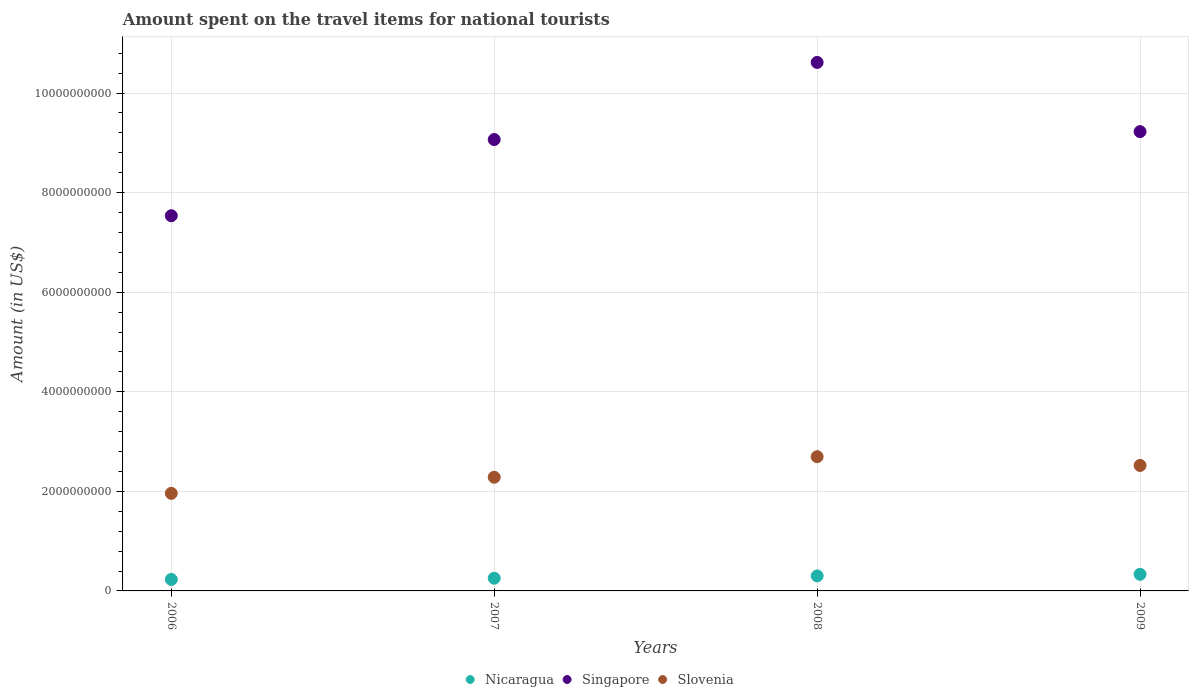Is the number of dotlines equal to the number of legend labels?
Offer a very short reply. Yes. What is the amount spent on the travel items for national tourists in Singapore in 2007?
Your answer should be compact. 9.07e+09. Across all years, what is the maximum amount spent on the travel items for national tourists in Slovenia?
Give a very brief answer. 2.70e+09. Across all years, what is the minimum amount spent on the travel items for national tourists in Slovenia?
Your answer should be compact. 1.96e+09. In which year was the amount spent on the travel items for national tourists in Nicaragua maximum?
Give a very brief answer. 2009. What is the total amount spent on the travel items for national tourists in Slovenia in the graph?
Offer a very short reply. 9.46e+09. What is the difference between the amount spent on the travel items for national tourists in Slovenia in 2007 and that in 2008?
Your answer should be very brief. -4.13e+08. What is the difference between the amount spent on the travel items for national tourists in Nicaragua in 2006 and the amount spent on the travel items for national tourists in Singapore in 2007?
Provide a short and direct response. -8.84e+09. What is the average amount spent on the travel items for national tourists in Singapore per year?
Offer a very short reply. 9.11e+09. In the year 2007, what is the difference between the amount spent on the travel items for national tourists in Slovenia and amount spent on the travel items for national tourists in Nicaragua?
Ensure brevity in your answer.  2.03e+09. What is the ratio of the amount spent on the travel items for national tourists in Slovenia in 2006 to that in 2008?
Ensure brevity in your answer.  0.73. Is the amount spent on the travel items for national tourists in Singapore in 2007 less than that in 2009?
Ensure brevity in your answer.  Yes. Is the difference between the amount spent on the travel items for national tourists in Slovenia in 2006 and 2009 greater than the difference between the amount spent on the travel items for national tourists in Nicaragua in 2006 and 2009?
Make the answer very short. No. What is the difference between the highest and the second highest amount spent on the travel items for national tourists in Singapore?
Your response must be concise. 1.39e+09. What is the difference between the highest and the lowest amount spent on the travel items for national tourists in Slovenia?
Provide a succinct answer. 7.36e+08. Does the amount spent on the travel items for national tourists in Slovenia monotonically increase over the years?
Your response must be concise. No. Is the amount spent on the travel items for national tourists in Slovenia strictly greater than the amount spent on the travel items for national tourists in Singapore over the years?
Offer a terse response. No. Is the amount spent on the travel items for national tourists in Singapore strictly less than the amount spent on the travel items for national tourists in Slovenia over the years?
Offer a terse response. No. How many dotlines are there?
Make the answer very short. 3. How many years are there in the graph?
Make the answer very short. 4. Are the values on the major ticks of Y-axis written in scientific E-notation?
Provide a short and direct response. No. Does the graph contain grids?
Offer a very short reply. Yes. How many legend labels are there?
Ensure brevity in your answer.  3. How are the legend labels stacked?
Keep it short and to the point. Horizontal. What is the title of the graph?
Offer a terse response. Amount spent on the travel items for national tourists. Does "Least developed countries" appear as one of the legend labels in the graph?
Provide a succinct answer. No. What is the label or title of the Y-axis?
Ensure brevity in your answer.  Amount (in US$). What is the Amount (in US$) in Nicaragua in 2006?
Provide a succinct answer. 2.31e+08. What is the Amount (in US$) of Singapore in 2006?
Offer a terse response. 7.54e+09. What is the Amount (in US$) of Slovenia in 2006?
Provide a short and direct response. 1.96e+09. What is the Amount (in US$) in Nicaragua in 2007?
Your response must be concise. 2.55e+08. What is the Amount (in US$) in Singapore in 2007?
Provide a short and direct response. 9.07e+09. What is the Amount (in US$) in Slovenia in 2007?
Ensure brevity in your answer.  2.28e+09. What is the Amount (in US$) of Nicaragua in 2008?
Provide a short and direct response. 3.01e+08. What is the Amount (in US$) of Singapore in 2008?
Your response must be concise. 1.06e+1. What is the Amount (in US$) in Slovenia in 2008?
Make the answer very short. 2.70e+09. What is the Amount (in US$) of Nicaragua in 2009?
Your answer should be very brief. 3.34e+08. What is the Amount (in US$) of Singapore in 2009?
Provide a short and direct response. 9.22e+09. What is the Amount (in US$) of Slovenia in 2009?
Offer a very short reply. 2.52e+09. Across all years, what is the maximum Amount (in US$) of Nicaragua?
Give a very brief answer. 3.34e+08. Across all years, what is the maximum Amount (in US$) in Singapore?
Make the answer very short. 1.06e+1. Across all years, what is the maximum Amount (in US$) in Slovenia?
Give a very brief answer. 2.70e+09. Across all years, what is the minimum Amount (in US$) of Nicaragua?
Offer a very short reply. 2.31e+08. Across all years, what is the minimum Amount (in US$) of Singapore?
Your answer should be very brief. 7.54e+09. Across all years, what is the minimum Amount (in US$) in Slovenia?
Provide a short and direct response. 1.96e+09. What is the total Amount (in US$) in Nicaragua in the graph?
Give a very brief answer. 1.12e+09. What is the total Amount (in US$) in Singapore in the graph?
Your answer should be very brief. 3.64e+1. What is the total Amount (in US$) in Slovenia in the graph?
Your response must be concise. 9.46e+09. What is the difference between the Amount (in US$) of Nicaragua in 2006 and that in 2007?
Your answer should be very brief. -2.40e+07. What is the difference between the Amount (in US$) of Singapore in 2006 and that in 2007?
Provide a short and direct response. -1.53e+09. What is the difference between the Amount (in US$) in Slovenia in 2006 and that in 2007?
Your answer should be very brief. -3.23e+08. What is the difference between the Amount (in US$) in Nicaragua in 2006 and that in 2008?
Your answer should be very brief. -7.00e+07. What is the difference between the Amount (in US$) in Singapore in 2006 and that in 2008?
Your response must be concise. -3.08e+09. What is the difference between the Amount (in US$) in Slovenia in 2006 and that in 2008?
Keep it short and to the point. -7.36e+08. What is the difference between the Amount (in US$) in Nicaragua in 2006 and that in 2009?
Offer a terse response. -1.03e+08. What is the difference between the Amount (in US$) of Singapore in 2006 and that in 2009?
Keep it short and to the point. -1.69e+09. What is the difference between the Amount (in US$) of Slovenia in 2006 and that in 2009?
Provide a succinct answer. -5.60e+08. What is the difference between the Amount (in US$) of Nicaragua in 2007 and that in 2008?
Keep it short and to the point. -4.60e+07. What is the difference between the Amount (in US$) in Singapore in 2007 and that in 2008?
Your answer should be compact. -1.55e+09. What is the difference between the Amount (in US$) of Slovenia in 2007 and that in 2008?
Provide a succinct answer. -4.13e+08. What is the difference between the Amount (in US$) of Nicaragua in 2007 and that in 2009?
Your response must be concise. -7.90e+07. What is the difference between the Amount (in US$) of Singapore in 2007 and that in 2009?
Ensure brevity in your answer.  -1.59e+08. What is the difference between the Amount (in US$) of Slovenia in 2007 and that in 2009?
Your answer should be compact. -2.37e+08. What is the difference between the Amount (in US$) in Nicaragua in 2008 and that in 2009?
Your answer should be very brief. -3.30e+07. What is the difference between the Amount (in US$) of Singapore in 2008 and that in 2009?
Provide a succinct answer. 1.39e+09. What is the difference between the Amount (in US$) in Slovenia in 2008 and that in 2009?
Provide a succinct answer. 1.76e+08. What is the difference between the Amount (in US$) in Nicaragua in 2006 and the Amount (in US$) in Singapore in 2007?
Provide a short and direct response. -8.84e+09. What is the difference between the Amount (in US$) of Nicaragua in 2006 and the Amount (in US$) of Slovenia in 2007?
Offer a very short reply. -2.05e+09. What is the difference between the Amount (in US$) of Singapore in 2006 and the Amount (in US$) of Slovenia in 2007?
Provide a succinct answer. 5.25e+09. What is the difference between the Amount (in US$) in Nicaragua in 2006 and the Amount (in US$) in Singapore in 2008?
Give a very brief answer. -1.04e+1. What is the difference between the Amount (in US$) of Nicaragua in 2006 and the Amount (in US$) of Slovenia in 2008?
Give a very brief answer. -2.46e+09. What is the difference between the Amount (in US$) in Singapore in 2006 and the Amount (in US$) in Slovenia in 2008?
Ensure brevity in your answer.  4.84e+09. What is the difference between the Amount (in US$) of Nicaragua in 2006 and the Amount (in US$) of Singapore in 2009?
Make the answer very short. -8.99e+09. What is the difference between the Amount (in US$) in Nicaragua in 2006 and the Amount (in US$) in Slovenia in 2009?
Keep it short and to the point. -2.29e+09. What is the difference between the Amount (in US$) of Singapore in 2006 and the Amount (in US$) of Slovenia in 2009?
Make the answer very short. 5.02e+09. What is the difference between the Amount (in US$) of Nicaragua in 2007 and the Amount (in US$) of Singapore in 2008?
Provide a short and direct response. -1.04e+1. What is the difference between the Amount (in US$) in Nicaragua in 2007 and the Amount (in US$) in Slovenia in 2008?
Make the answer very short. -2.44e+09. What is the difference between the Amount (in US$) in Singapore in 2007 and the Amount (in US$) in Slovenia in 2008?
Your answer should be very brief. 6.37e+09. What is the difference between the Amount (in US$) of Nicaragua in 2007 and the Amount (in US$) of Singapore in 2009?
Keep it short and to the point. -8.97e+09. What is the difference between the Amount (in US$) of Nicaragua in 2007 and the Amount (in US$) of Slovenia in 2009?
Keep it short and to the point. -2.26e+09. What is the difference between the Amount (in US$) in Singapore in 2007 and the Amount (in US$) in Slovenia in 2009?
Offer a very short reply. 6.55e+09. What is the difference between the Amount (in US$) in Nicaragua in 2008 and the Amount (in US$) in Singapore in 2009?
Make the answer very short. -8.92e+09. What is the difference between the Amount (in US$) in Nicaragua in 2008 and the Amount (in US$) in Slovenia in 2009?
Provide a short and direct response. -2.22e+09. What is the difference between the Amount (in US$) in Singapore in 2008 and the Amount (in US$) in Slovenia in 2009?
Make the answer very short. 8.10e+09. What is the average Amount (in US$) of Nicaragua per year?
Ensure brevity in your answer.  2.80e+08. What is the average Amount (in US$) of Singapore per year?
Offer a terse response. 9.11e+09. What is the average Amount (in US$) in Slovenia per year?
Your response must be concise. 2.36e+09. In the year 2006, what is the difference between the Amount (in US$) of Nicaragua and Amount (in US$) of Singapore?
Provide a short and direct response. -7.30e+09. In the year 2006, what is the difference between the Amount (in US$) of Nicaragua and Amount (in US$) of Slovenia?
Provide a succinct answer. -1.73e+09. In the year 2006, what is the difference between the Amount (in US$) of Singapore and Amount (in US$) of Slovenia?
Your response must be concise. 5.58e+09. In the year 2007, what is the difference between the Amount (in US$) in Nicaragua and Amount (in US$) in Singapore?
Offer a very short reply. -8.81e+09. In the year 2007, what is the difference between the Amount (in US$) in Nicaragua and Amount (in US$) in Slovenia?
Give a very brief answer. -2.03e+09. In the year 2007, what is the difference between the Amount (in US$) of Singapore and Amount (in US$) of Slovenia?
Provide a short and direct response. 6.78e+09. In the year 2008, what is the difference between the Amount (in US$) in Nicaragua and Amount (in US$) in Singapore?
Give a very brief answer. -1.03e+1. In the year 2008, what is the difference between the Amount (in US$) in Nicaragua and Amount (in US$) in Slovenia?
Ensure brevity in your answer.  -2.40e+09. In the year 2008, what is the difference between the Amount (in US$) of Singapore and Amount (in US$) of Slovenia?
Give a very brief answer. 7.92e+09. In the year 2009, what is the difference between the Amount (in US$) of Nicaragua and Amount (in US$) of Singapore?
Ensure brevity in your answer.  -8.89e+09. In the year 2009, what is the difference between the Amount (in US$) in Nicaragua and Amount (in US$) in Slovenia?
Your answer should be compact. -2.19e+09. In the year 2009, what is the difference between the Amount (in US$) in Singapore and Amount (in US$) in Slovenia?
Your response must be concise. 6.70e+09. What is the ratio of the Amount (in US$) of Nicaragua in 2006 to that in 2007?
Ensure brevity in your answer.  0.91. What is the ratio of the Amount (in US$) in Singapore in 2006 to that in 2007?
Give a very brief answer. 0.83. What is the ratio of the Amount (in US$) in Slovenia in 2006 to that in 2007?
Make the answer very short. 0.86. What is the ratio of the Amount (in US$) of Nicaragua in 2006 to that in 2008?
Offer a very short reply. 0.77. What is the ratio of the Amount (in US$) in Singapore in 2006 to that in 2008?
Make the answer very short. 0.71. What is the ratio of the Amount (in US$) of Slovenia in 2006 to that in 2008?
Provide a short and direct response. 0.73. What is the ratio of the Amount (in US$) in Nicaragua in 2006 to that in 2009?
Provide a succinct answer. 0.69. What is the ratio of the Amount (in US$) in Singapore in 2006 to that in 2009?
Your answer should be very brief. 0.82. What is the ratio of the Amount (in US$) in Nicaragua in 2007 to that in 2008?
Your answer should be very brief. 0.85. What is the ratio of the Amount (in US$) of Singapore in 2007 to that in 2008?
Your answer should be very brief. 0.85. What is the ratio of the Amount (in US$) in Slovenia in 2007 to that in 2008?
Offer a very short reply. 0.85. What is the ratio of the Amount (in US$) of Nicaragua in 2007 to that in 2009?
Make the answer very short. 0.76. What is the ratio of the Amount (in US$) in Singapore in 2007 to that in 2009?
Offer a very short reply. 0.98. What is the ratio of the Amount (in US$) of Slovenia in 2007 to that in 2009?
Keep it short and to the point. 0.91. What is the ratio of the Amount (in US$) in Nicaragua in 2008 to that in 2009?
Make the answer very short. 0.9. What is the ratio of the Amount (in US$) in Singapore in 2008 to that in 2009?
Offer a terse response. 1.15. What is the ratio of the Amount (in US$) of Slovenia in 2008 to that in 2009?
Your answer should be very brief. 1.07. What is the difference between the highest and the second highest Amount (in US$) of Nicaragua?
Your answer should be very brief. 3.30e+07. What is the difference between the highest and the second highest Amount (in US$) in Singapore?
Offer a very short reply. 1.39e+09. What is the difference between the highest and the second highest Amount (in US$) of Slovenia?
Offer a terse response. 1.76e+08. What is the difference between the highest and the lowest Amount (in US$) of Nicaragua?
Your answer should be compact. 1.03e+08. What is the difference between the highest and the lowest Amount (in US$) of Singapore?
Give a very brief answer. 3.08e+09. What is the difference between the highest and the lowest Amount (in US$) of Slovenia?
Provide a succinct answer. 7.36e+08. 